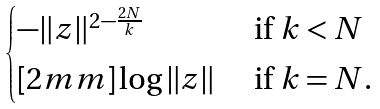Convert formula to latex. <formula><loc_0><loc_0><loc_500><loc_500>\begin{cases} - \| z \| ^ { 2 - \frac { 2 N } { k } } & \text { if } k < N \\ [ 2 m m ] \log \| z \| & \text { if } k = N . \end{cases}</formula> 